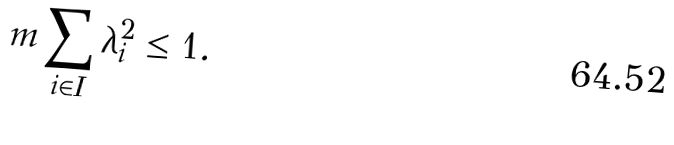<formula> <loc_0><loc_0><loc_500><loc_500>m \sum _ { i \in I } \lambda _ { i } ^ { 2 } \leq 1 .</formula> 